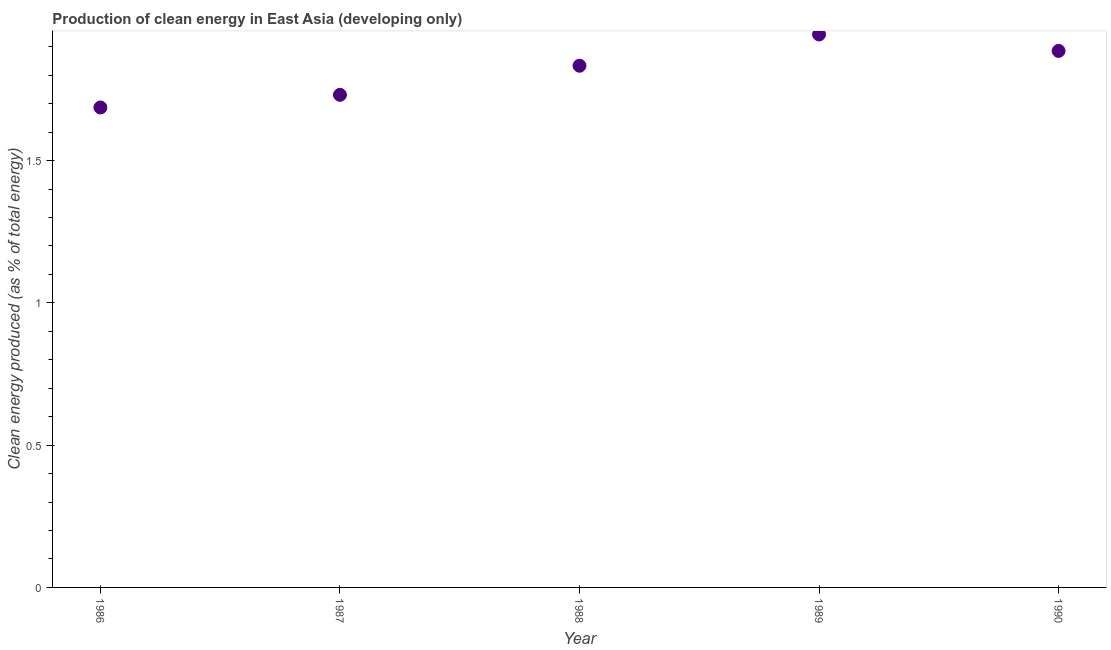What is the production of clean energy in 1988?
Ensure brevity in your answer.  1.83. Across all years, what is the maximum production of clean energy?
Keep it short and to the point. 1.94. Across all years, what is the minimum production of clean energy?
Provide a short and direct response. 1.69. In which year was the production of clean energy maximum?
Make the answer very short. 1989. In which year was the production of clean energy minimum?
Offer a terse response. 1986. What is the sum of the production of clean energy?
Make the answer very short. 9.08. What is the difference between the production of clean energy in 1986 and 1989?
Offer a terse response. -0.26. What is the average production of clean energy per year?
Offer a terse response. 1.82. What is the median production of clean energy?
Your response must be concise. 1.83. In how many years, is the production of clean energy greater than 0.1 %?
Offer a terse response. 5. What is the ratio of the production of clean energy in 1986 to that in 1987?
Offer a very short reply. 0.97. Is the production of clean energy in 1986 less than that in 1988?
Keep it short and to the point. Yes. What is the difference between the highest and the second highest production of clean energy?
Offer a terse response. 0.06. What is the difference between the highest and the lowest production of clean energy?
Give a very brief answer. 0.26. In how many years, is the production of clean energy greater than the average production of clean energy taken over all years?
Keep it short and to the point. 3. What is the difference between two consecutive major ticks on the Y-axis?
Give a very brief answer. 0.5. What is the title of the graph?
Ensure brevity in your answer.  Production of clean energy in East Asia (developing only). What is the label or title of the Y-axis?
Your response must be concise. Clean energy produced (as % of total energy). What is the Clean energy produced (as % of total energy) in 1986?
Offer a terse response. 1.69. What is the Clean energy produced (as % of total energy) in 1987?
Give a very brief answer. 1.73. What is the Clean energy produced (as % of total energy) in 1988?
Give a very brief answer. 1.83. What is the Clean energy produced (as % of total energy) in 1989?
Offer a very short reply. 1.94. What is the Clean energy produced (as % of total energy) in 1990?
Provide a succinct answer. 1.89. What is the difference between the Clean energy produced (as % of total energy) in 1986 and 1987?
Offer a very short reply. -0.04. What is the difference between the Clean energy produced (as % of total energy) in 1986 and 1988?
Offer a very short reply. -0.15. What is the difference between the Clean energy produced (as % of total energy) in 1986 and 1989?
Your answer should be compact. -0.26. What is the difference between the Clean energy produced (as % of total energy) in 1986 and 1990?
Your answer should be very brief. -0.2. What is the difference between the Clean energy produced (as % of total energy) in 1987 and 1988?
Give a very brief answer. -0.1. What is the difference between the Clean energy produced (as % of total energy) in 1987 and 1989?
Give a very brief answer. -0.21. What is the difference between the Clean energy produced (as % of total energy) in 1987 and 1990?
Offer a terse response. -0.15. What is the difference between the Clean energy produced (as % of total energy) in 1988 and 1989?
Your response must be concise. -0.11. What is the difference between the Clean energy produced (as % of total energy) in 1988 and 1990?
Keep it short and to the point. -0.05. What is the difference between the Clean energy produced (as % of total energy) in 1989 and 1990?
Your answer should be very brief. 0.06. What is the ratio of the Clean energy produced (as % of total energy) in 1986 to that in 1987?
Give a very brief answer. 0.97. What is the ratio of the Clean energy produced (as % of total energy) in 1986 to that in 1989?
Make the answer very short. 0.87. What is the ratio of the Clean energy produced (as % of total energy) in 1986 to that in 1990?
Offer a terse response. 0.9. What is the ratio of the Clean energy produced (as % of total energy) in 1987 to that in 1988?
Provide a short and direct response. 0.94. What is the ratio of the Clean energy produced (as % of total energy) in 1987 to that in 1989?
Keep it short and to the point. 0.89. What is the ratio of the Clean energy produced (as % of total energy) in 1987 to that in 1990?
Make the answer very short. 0.92. What is the ratio of the Clean energy produced (as % of total energy) in 1988 to that in 1989?
Offer a very short reply. 0.94. What is the ratio of the Clean energy produced (as % of total energy) in 1989 to that in 1990?
Make the answer very short. 1.03. 